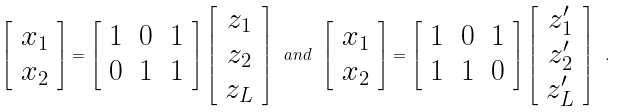<formula> <loc_0><loc_0><loc_500><loc_500>\left [ \begin{array} { c } x _ { 1 } \\ x _ { 2 } \end{array} \right ] = \left [ \begin{array} { c c c } 1 & 0 & 1 \\ 0 & 1 & 1 \end{array} \right ] \left [ \begin{array} { c } z _ { 1 } \\ z _ { 2 } \\ z _ { L } \end{array} \right ] \ a n d \ \left [ \begin{array} { c } x _ { 1 } \\ x _ { 2 } \end{array} \right ] = \left [ \begin{array} { c c c } 1 & 0 & 1 \\ 1 & 1 & 0 \end{array} \right ] \left [ \begin{array} { c } z ^ { \prime } _ { 1 } \\ z ^ { \prime } _ { 2 } \\ z ^ { \prime } _ { L } \end{array} \right ] \ .</formula> 